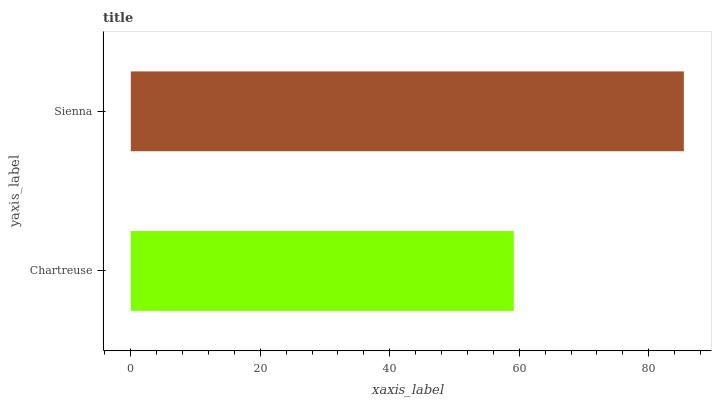Is Chartreuse the minimum?
Answer yes or no. Yes. Is Sienna the maximum?
Answer yes or no. Yes. Is Sienna the minimum?
Answer yes or no. No. Is Sienna greater than Chartreuse?
Answer yes or no. Yes. Is Chartreuse less than Sienna?
Answer yes or no. Yes. Is Chartreuse greater than Sienna?
Answer yes or no. No. Is Sienna less than Chartreuse?
Answer yes or no. No. Is Sienna the high median?
Answer yes or no. Yes. Is Chartreuse the low median?
Answer yes or no. Yes. Is Chartreuse the high median?
Answer yes or no. No. Is Sienna the low median?
Answer yes or no. No. 